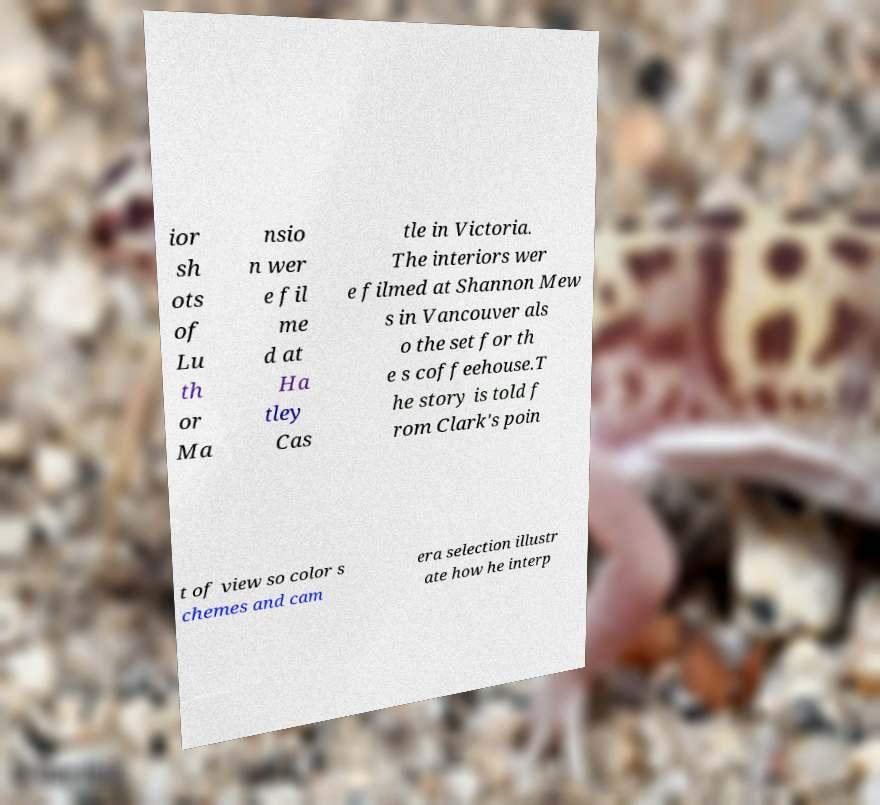I need the written content from this picture converted into text. Can you do that? ior sh ots of Lu th or Ma nsio n wer e fil me d at Ha tley Cas tle in Victoria. The interiors wer e filmed at Shannon Mew s in Vancouver als o the set for th e s coffeehouse.T he story is told f rom Clark's poin t of view so color s chemes and cam era selection illustr ate how he interp 